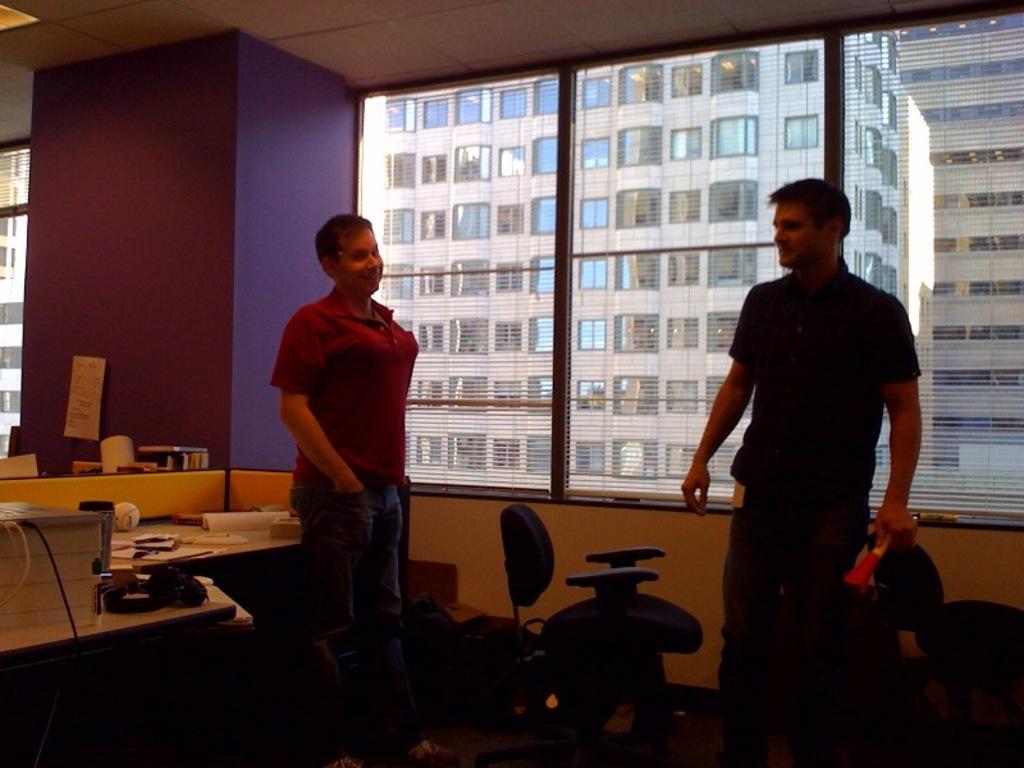Describe this image in one or two sentences. It is a room inside the office there are two men standing, behind the man who is on the left side there is a table and in between them there are two chairs in the background there is a window out side the window there is a building. 